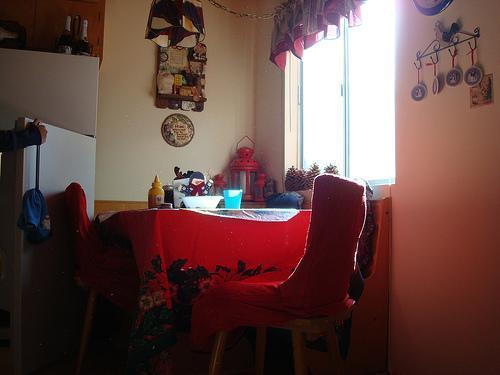How many yellow bottles are in the image?
Give a very brief answer. 1. 